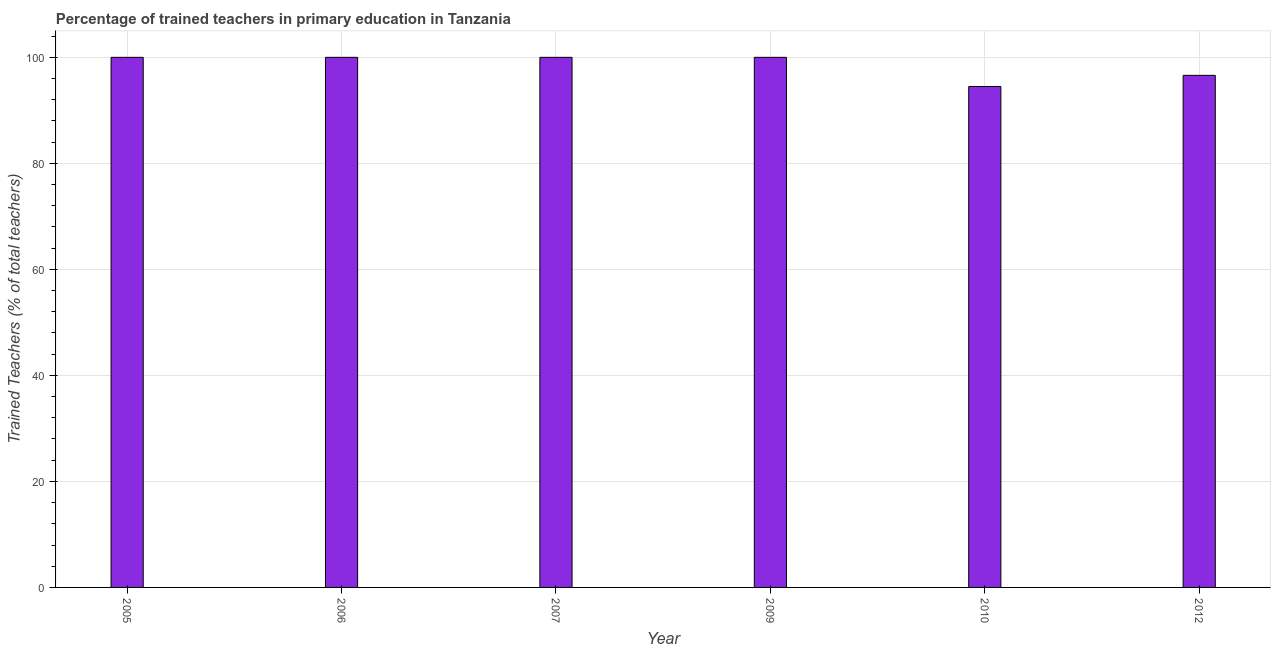Does the graph contain any zero values?
Make the answer very short. No. What is the title of the graph?
Your response must be concise. Percentage of trained teachers in primary education in Tanzania. What is the label or title of the X-axis?
Provide a succinct answer. Year. What is the label or title of the Y-axis?
Offer a very short reply. Trained Teachers (% of total teachers). What is the percentage of trained teachers in 2012?
Offer a terse response. 96.6. Across all years, what is the maximum percentage of trained teachers?
Your answer should be very brief. 100. Across all years, what is the minimum percentage of trained teachers?
Provide a succinct answer. 94.5. In which year was the percentage of trained teachers maximum?
Make the answer very short. 2005. What is the sum of the percentage of trained teachers?
Your answer should be very brief. 591.1. What is the difference between the percentage of trained teachers in 2009 and 2010?
Keep it short and to the point. 5.5. What is the average percentage of trained teachers per year?
Your response must be concise. 98.52. What is the median percentage of trained teachers?
Ensure brevity in your answer.  100. In how many years, is the percentage of trained teachers greater than 96 %?
Provide a short and direct response. 5. Is the percentage of trained teachers in 2009 less than that in 2012?
Give a very brief answer. No. What is the difference between the highest and the second highest percentage of trained teachers?
Keep it short and to the point. 0. What is the difference between the highest and the lowest percentage of trained teachers?
Your response must be concise. 5.5. In how many years, is the percentage of trained teachers greater than the average percentage of trained teachers taken over all years?
Provide a succinct answer. 4. How many bars are there?
Your answer should be compact. 6. How many years are there in the graph?
Provide a succinct answer. 6. What is the Trained Teachers (% of total teachers) in 2009?
Offer a very short reply. 100. What is the Trained Teachers (% of total teachers) in 2010?
Provide a succinct answer. 94.5. What is the Trained Teachers (% of total teachers) of 2012?
Give a very brief answer. 96.6. What is the difference between the Trained Teachers (% of total teachers) in 2005 and 2006?
Provide a succinct answer. 0. What is the difference between the Trained Teachers (% of total teachers) in 2005 and 2010?
Your answer should be very brief. 5.5. What is the difference between the Trained Teachers (% of total teachers) in 2005 and 2012?
Provide a succinct answer. 3.4. What is the difference between the Trained Teachers (% of total teachers) in 2006 and 2009?
Your response must be concise. 0. What is the difference between the Trained Teachers (% of total teachers) in 2006 and 2010?
Provide a short and direct response. 5.5. What is the difference between the Trained Teachers (% of total teachers) in 2006 and 2012?
Ensure brevity in your answer.  3.4. What is the difference between the Trained Teachers (% of total teachers) in 2007 and 2010?
Give a very brief answer. 5.5. What is the difference between the Trained Teachers (% of total teachers) in 2007 and 2012?
Provide a succinct answer. 3.4. What is the difference between the Trained Teachers (% of total teachers) in 2009 and 2010?
Offer a terse response. 5.5. What is the difference between the Trained Teachers (% of total teachers) in 2009 and 2012?
Your answer should be very brief. 3.4. What is the difference between the Trained Teachers (% of total teachers) in 2010 and 2012?
Keep it short and to the point. -2.1. What is the ratio of the Trained Teachers (% of total teachers) in 2005 to that in 2007?
Give a very brief answer. 1. What is the ratio of the Trained Teachers (% of total teachers) in 2005 to that in 2009?
Your response must be concise. 1. What is the ratio of the Trained Teachers (% of total teachers) in 2005 to that in 2010?
Your answer should be compact. 1.06. What is the ratio of the Trained Teachers (% of total teachers) in 2005 to that in 2012?
Ensure brevity in your answer.  1.03. What is the ratio of the Trained Teachers (% of total teachers) in 2006 to that in 2007?
Ensure brevity in your answer.  1. What is the ratio of the Trained Teachers (% of total teachers) in 2006 to that in 2010?
Offer a terse response. 1.06. What is the ratio of the Trained Teachers (% of total teachers) in 2006 to that in 2012?
Provide a short and direct response. 1.03. What is the ratio of the Trained Teachers (% of total teachers) in 2007 to that in 2010?
Offer a terse response. 1.06. What is the ratio of the Trained Teachers (% of total teachers) in 2007 to that in 2012?
Make the answer very short. 1.03. What is the ratio of the Trained Teachers (% of total teachers) in 2009 to that in 2010?
Give a very brief answer. 1.06. What is the ratio of the Trained Teachers (% of total teachers) in 2009 to that in 2012?
Offer a very short reply. 1.03. What is the ratio of the Trained Teachers (% of total teachers) in 2010 to that in 2012?
Offer a very short reply. 0.98. 